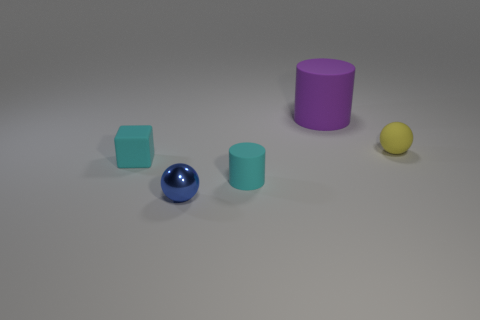Is there anything else that has the same material as the small blue sphere?
Provide a short and direct response. No. What number of big objects have the same color as the tiny block?
Ensure brevity in your answer.  0. The small metallic sphere is what color?
Keep it short and to the point. Blue. How many cylinders are left of the thing behind the yellow rubber thing?
Your answer should be very brief. 1. Is the size of the yellow thing the same as the cyan matte thing that is on the left side of the tiny blue shiny object?
Keep it short and to the point. Yes. Does the cyan block have the same size as the metal thing?
Offer a very short reply. Yes. Are there any other blue metal balls of the same size as the blue ball?
Give a very brief answer. No. There is a object left of the small blue sphere; what material is it?
Provide a short and direct response. Rubber. There is a big thing that is made of the same material as the small cylinder; what is its color?
Keep it short and to the point. Purple. What number of metal things are either tiny yellow balls or green cylinders?
Your answer should be very brief. 0. 